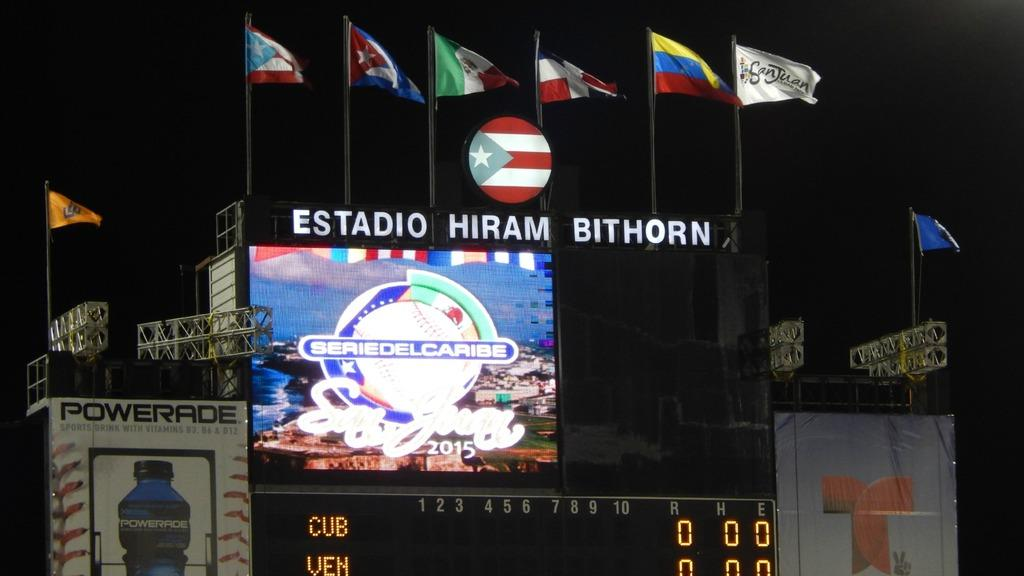<image>
Relay a brief, clear account of the picture shown. The Estadio Hiram Bithorn showing the score of a baseball game between Cuba and Venezuela. 